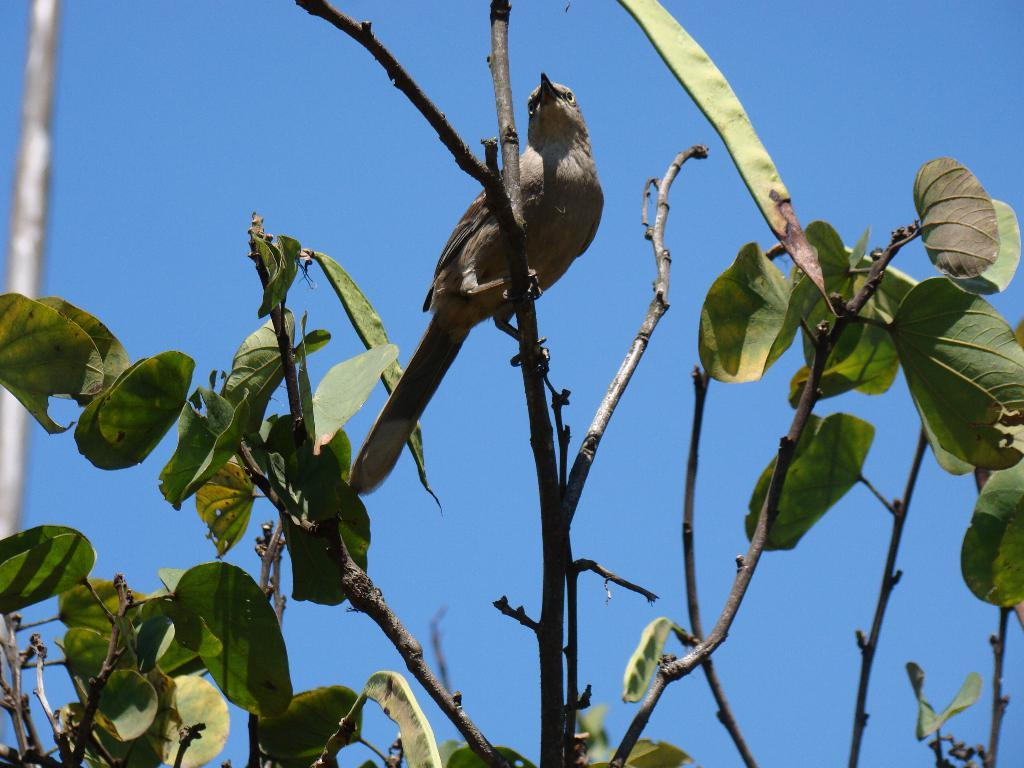What animal can be seen in the picture? There is a bird in the picture. Where is the bird located in the image? The bird is standing on the stem of a tree. What else can be seen near the bird? There are leaves beside the bird. What type of drain is visible in the picture? There is no drain present in the picture; it features a bird standing on a tree stem with leaves nearby. 